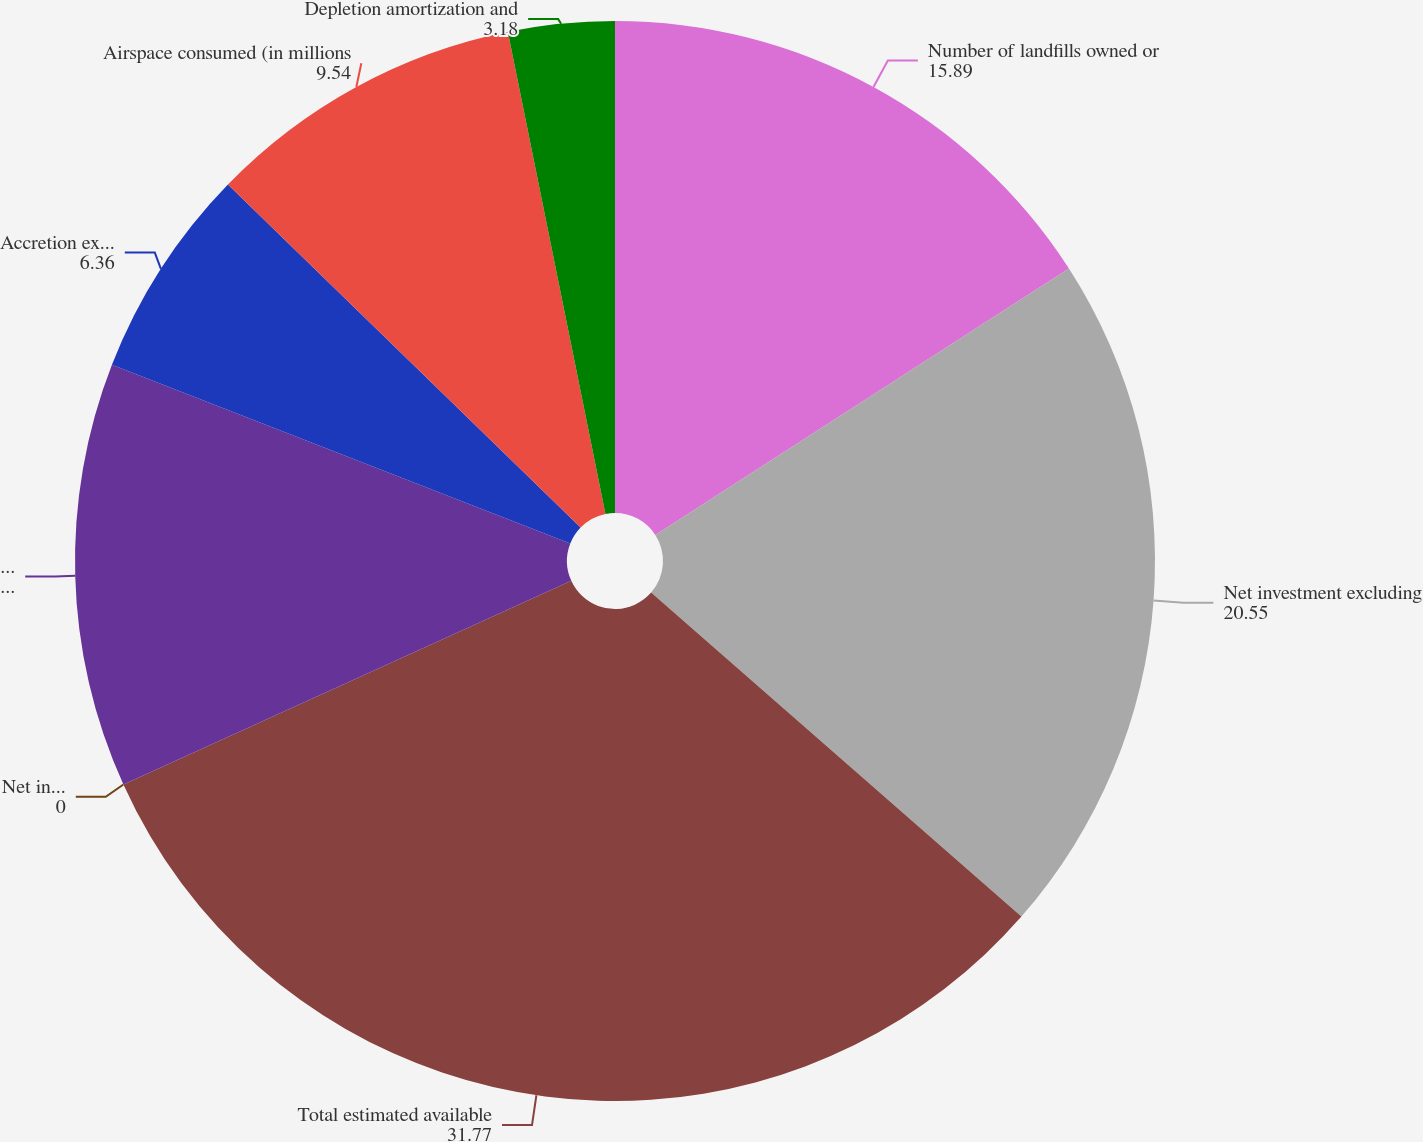<chart> <loc_0><loc_0><loc_500><loc_500><pie_chart><fcel>Number of landfills owned or<fcel>Net investment excluding<fcel>Total estimated available<fcel>Net investment per cubic yard<fcel>Landfill depletion and<fcel>Accretion expense (in<fcel>Airspace consumed (in millions<fcel>Depletion amortization and<nl><fcel>15.89%<fcel>20.55%<fcel>31.77%<fcel>0.0%<fcel>12.71%<fcel>6.36%<fcel>9.54%<fcel>3.18%<nl></chart> 